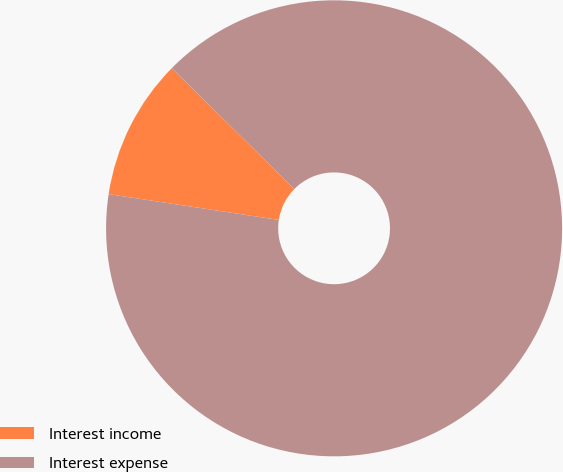Convert chart. <chart><loc_0><loc_0><loc_500><loc_500><pie_chart><fcel>Interest income<fcel>Interest expense<nl><fcel>10.0%<fcel>90.0%<nl></chart> 